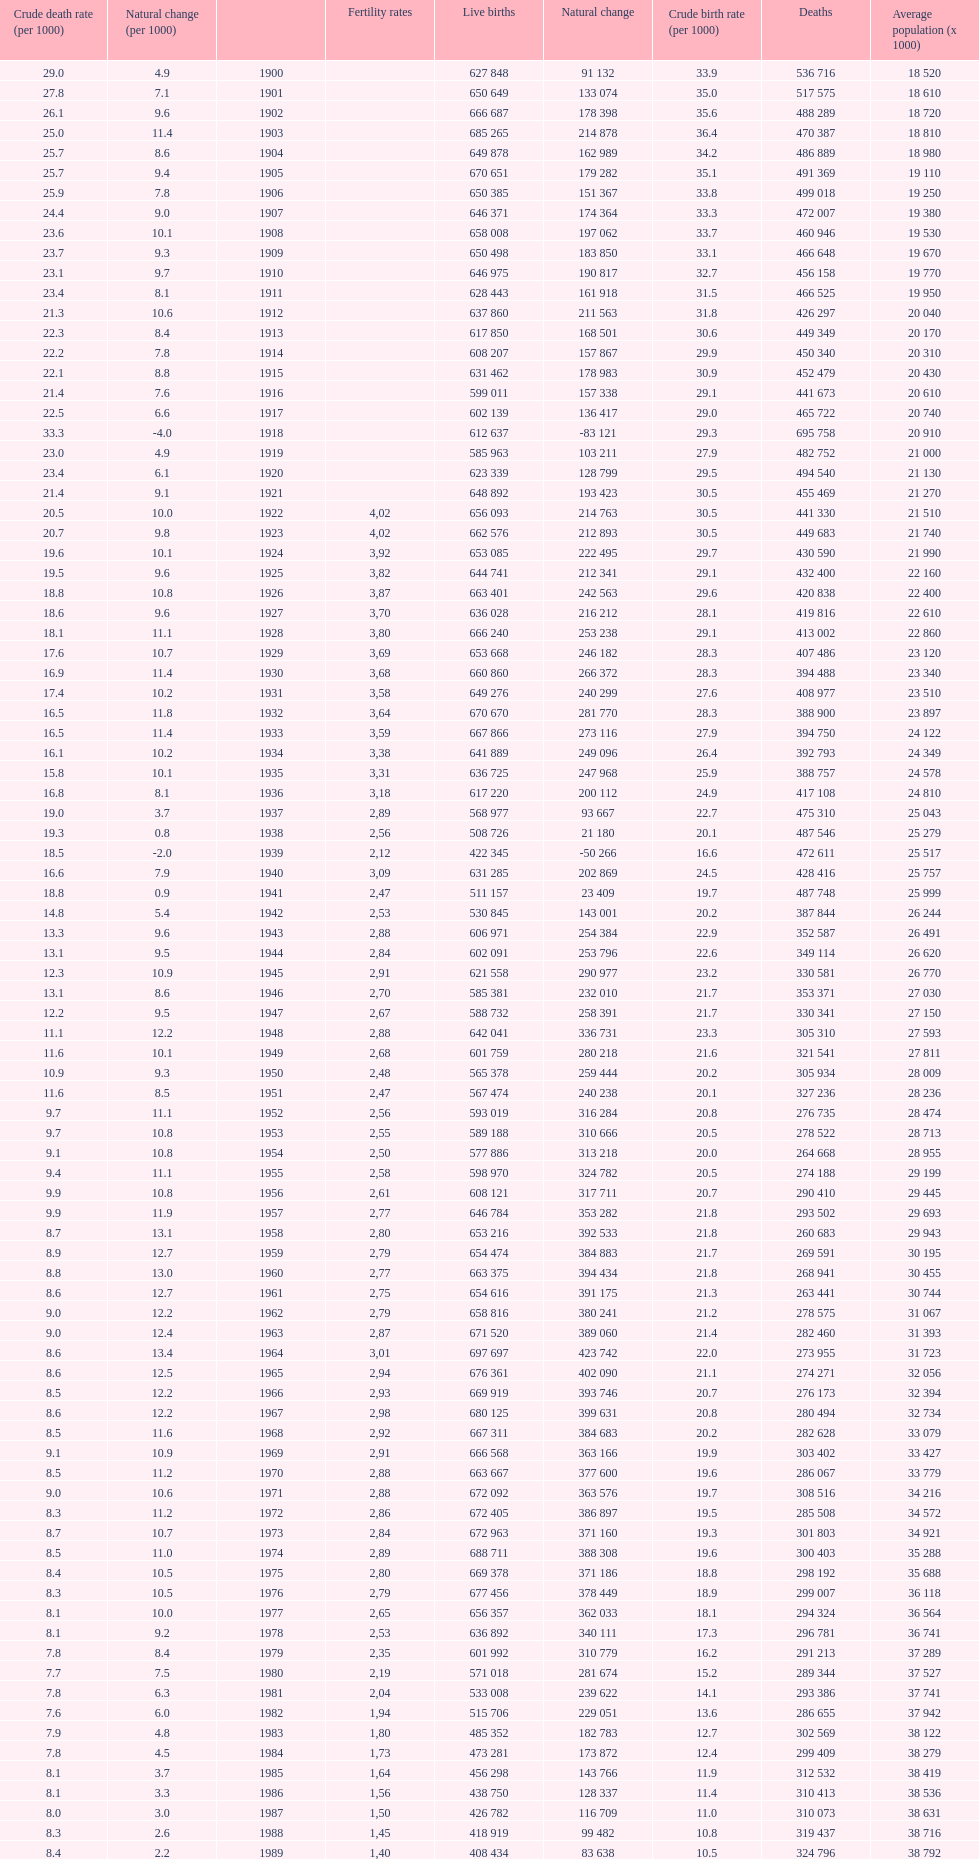Which year has a crude birth rate of 29.1 with a population of 22,860? 1928. 